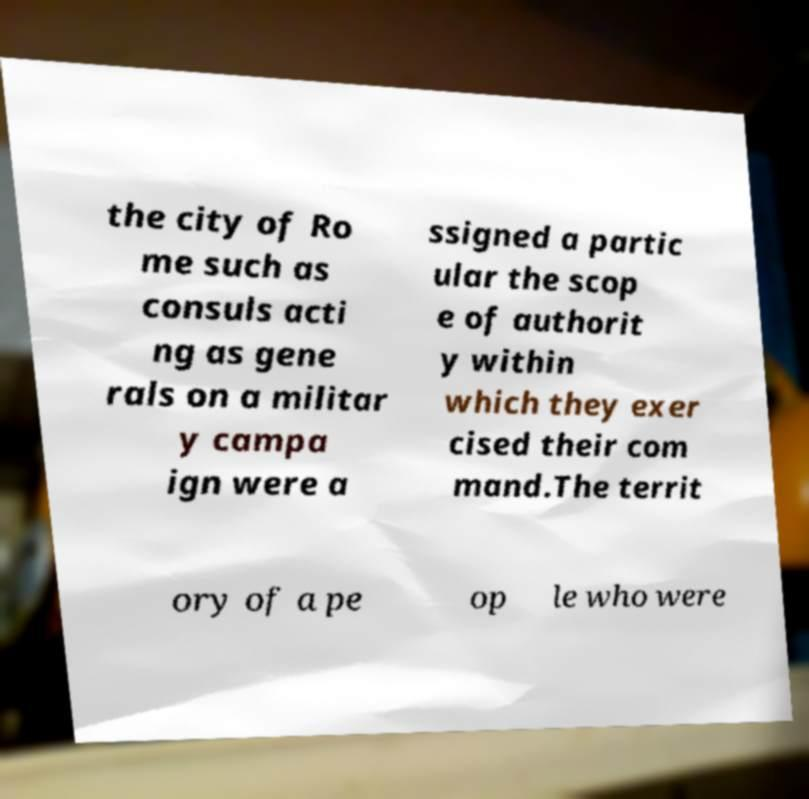Can you read and provide the text displayed in the image?This photo seems to have some interesting text. Can you extract and type it out for me? the city of Ro me such as consuls acti ng as gene rals on a militar y campa ign were a ssigned a partic ular the scop e of authorit y within which they exer cised their com mand.The territ ory of a pe op le who were 